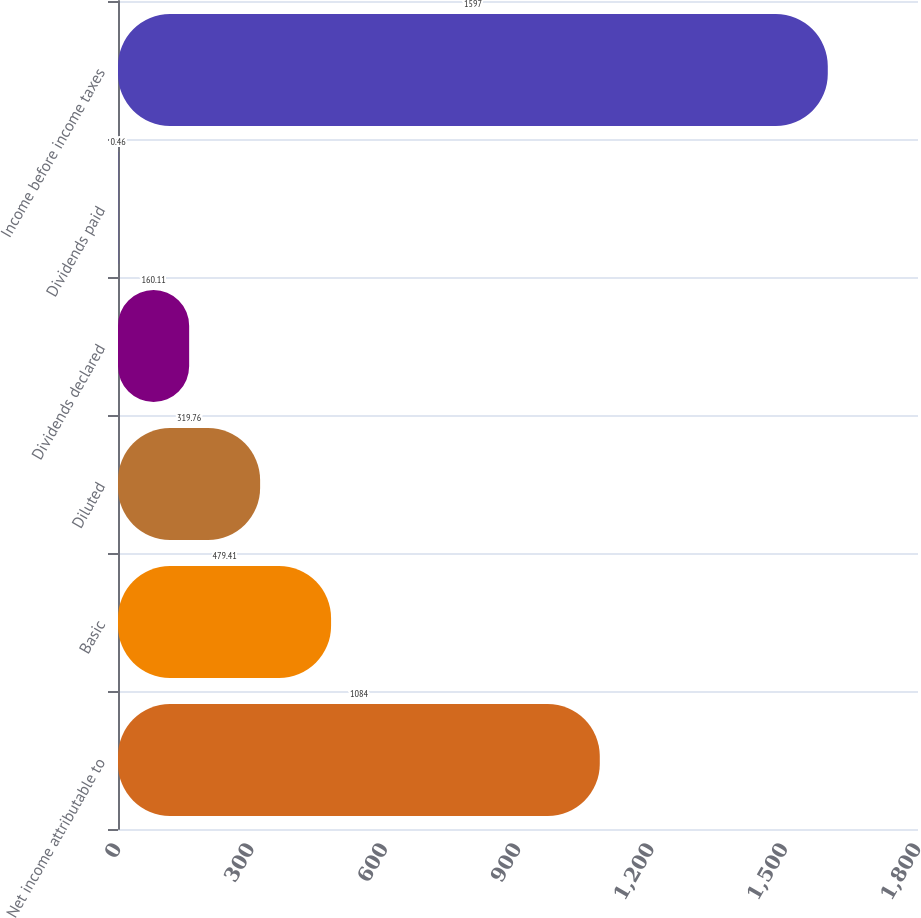Convert chart to OTSL. <chart><loc_0><loc_0><loc_500><loc_500><bar_chart><fcel>Net income attributable to<fcel>Basic<fcel>Diluted<fcel>Dividends declared<fcel>Dividends paid<fcel>Income before income taxes<nl><fcel>1084<fcel>479.41<fcel>319.76<fcel>160.11<fcel>0.46<fcel>1597<nl></chart> 